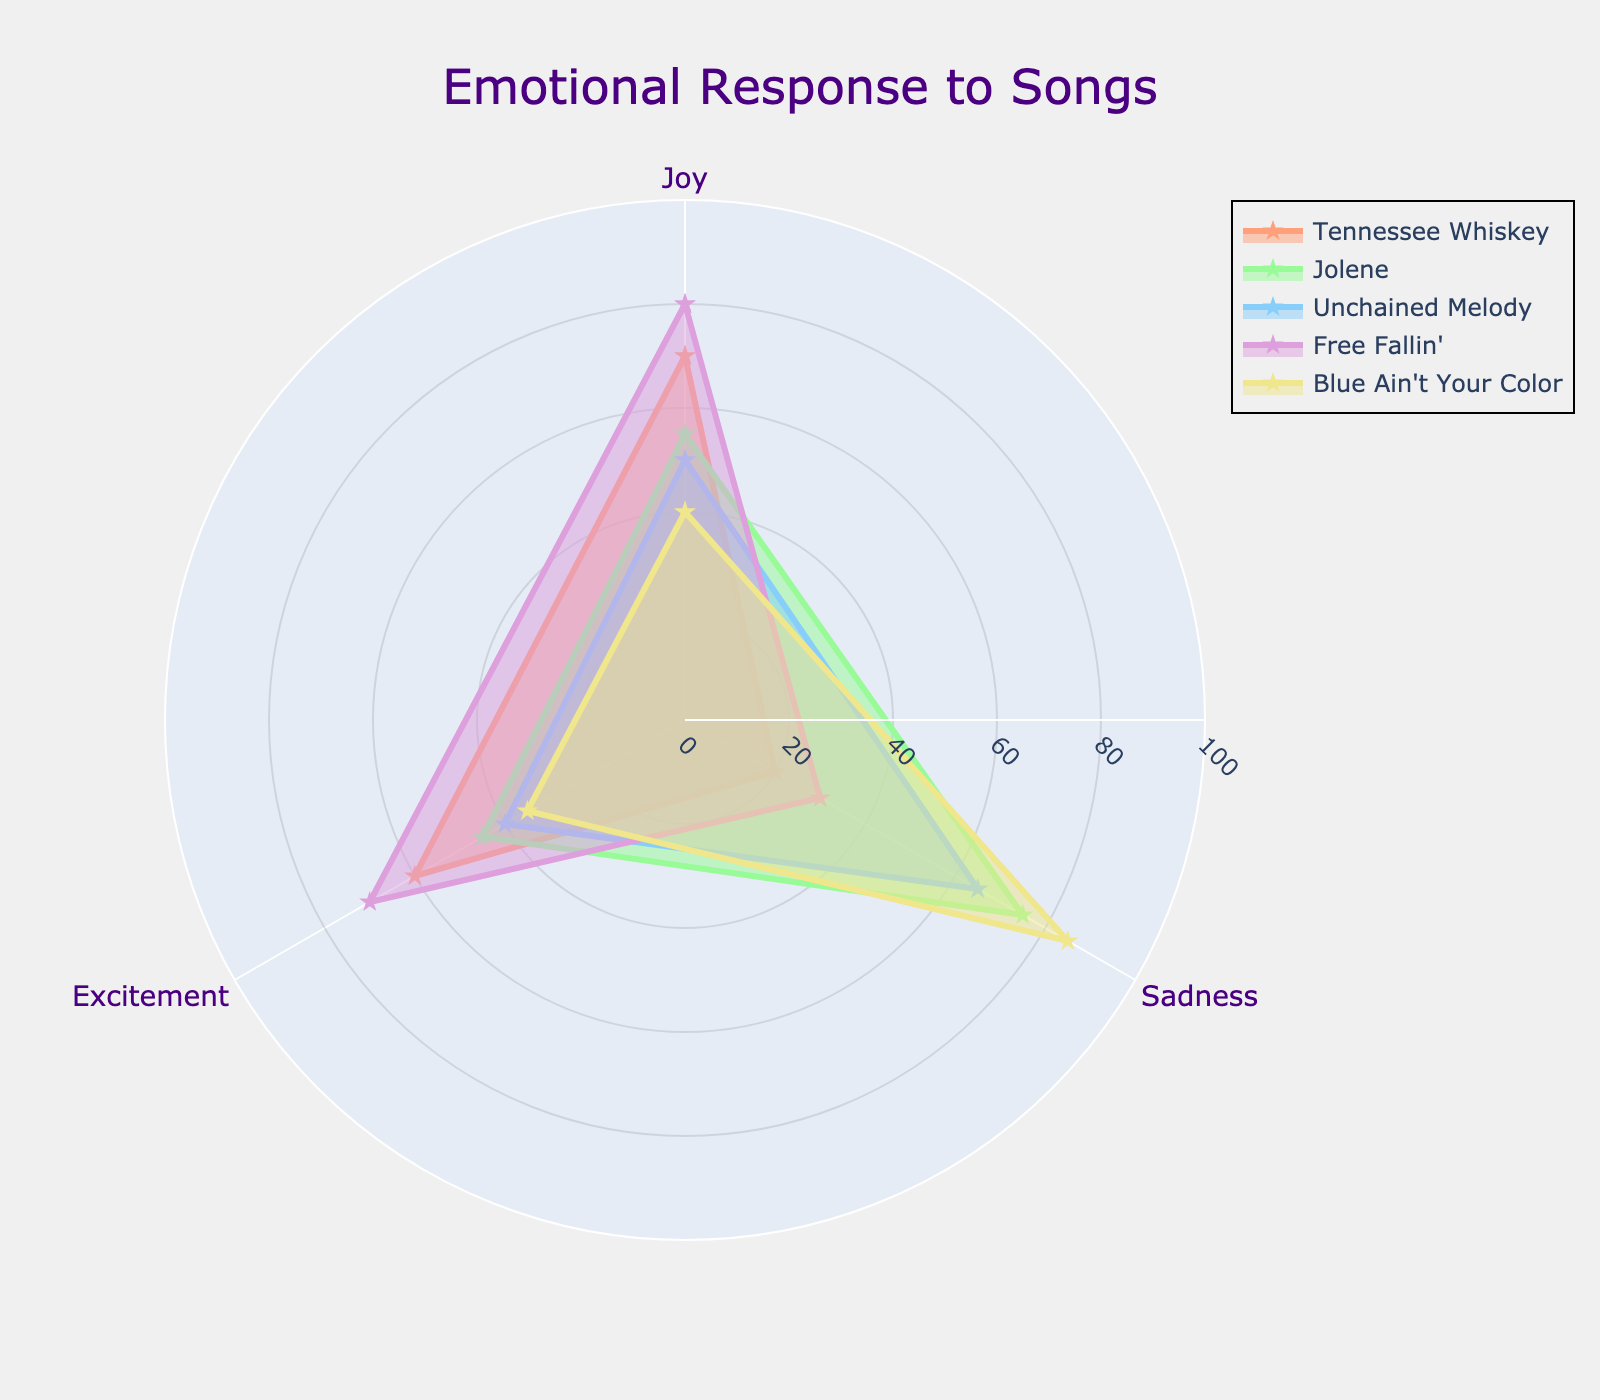Who has the highest "Joy" rating? Look at the "Joy" axis and observe the values for each song. "Free Fallin'" has the highest "Joy" rating at 80.
Answer: Free Fallin' Which song has the greatest difference between "Joy" and "Sadness"? Calculate the difference between "Joy" and "Sadness" for each song: "Tennessee Whiskey" (70-20=50), "Jolene" (55-75=-20), "Unchained Melody" (50-65=-15), "Free Fallin'" (80-30=50), "Blue Ain't Your Color" (40-85=-45). Both "Tennessee Whiskey" and "Free Fallin'" have a difference of 50.
Answer: Tennessee Whiskey and Free Fallin' Which song evokes the highest overall emotional response when adding "Joy," "Sadness," and "Excitement"? Add up the "Joy," "Sadness," and "Excitement" values for each song: "Tennessee Whiskey" (70+20+60=150), "Jolene" (55+75+45=175), "Unchained Melody" (50+65+40=155), "Free Fallin'" (80+30+70=180), "Blue Ain't Your Color" (40+85+35=160). "Free Fallin'" has the highest total at 180.
Answer: Free Fallin' Which song incites more "Joy" than "Excitement"? Compare the "Joy" and "Excitement" values of each song: "Tennessee Whiskey" (70 > 60), "Jolene" (55 < 45), "Unchained Melody" (50 > 40), "Free Fallin'" (80 > 70), "Blue Ain't Your Color" (40 > 35). All songs except "Jolene" show more "Joy" than "Excitement."
Answer: Tennessee Whiskey, Unchained Melody, Free Fallin', Blue Ain't Your Color Which song induces the lowest "Sadness"? Look at the "Sadness" axis and observe the values for each song. "Tennessee Whiskey" has the lowest "Sadness" rating at 20.
Answer: Tennessee Whiskey What is the average "Excitement" rating of all the songs? Add the "Excitement" values: (60+45+40+70+35=250). Divide by the number of songs (250/5=50).
Answer: 50 